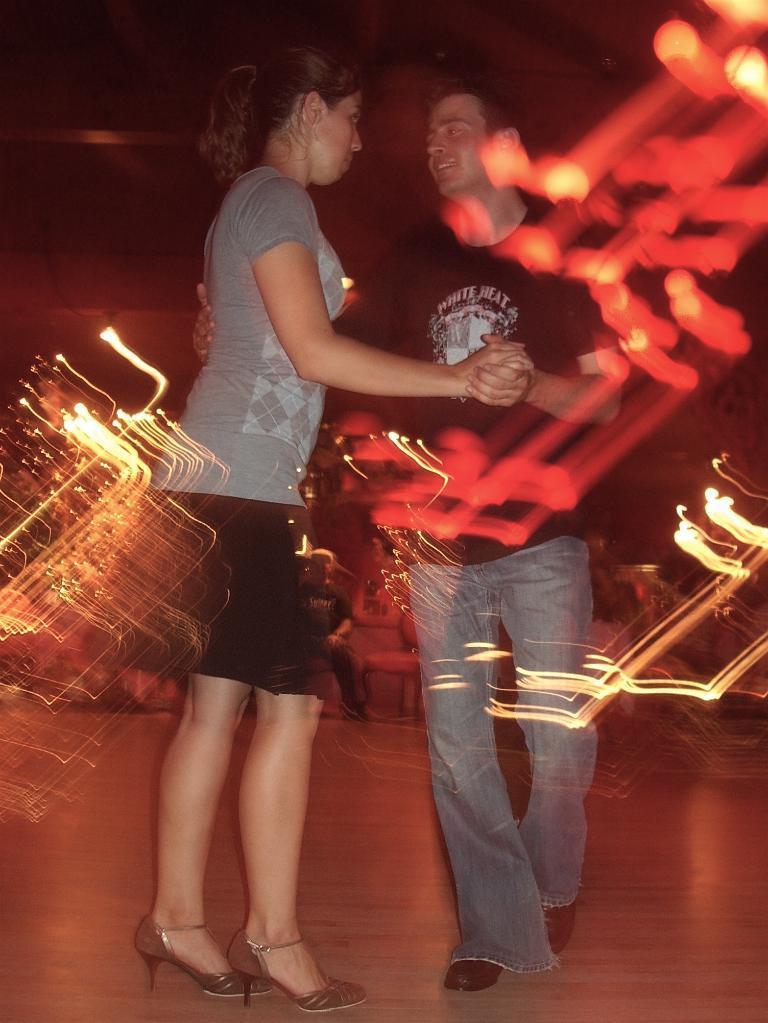Could you give a brief overview of what you see in this image? In this image there is a couple dancing on the floor, behind them there is a person sitting on one of the chairs and some lighting. 